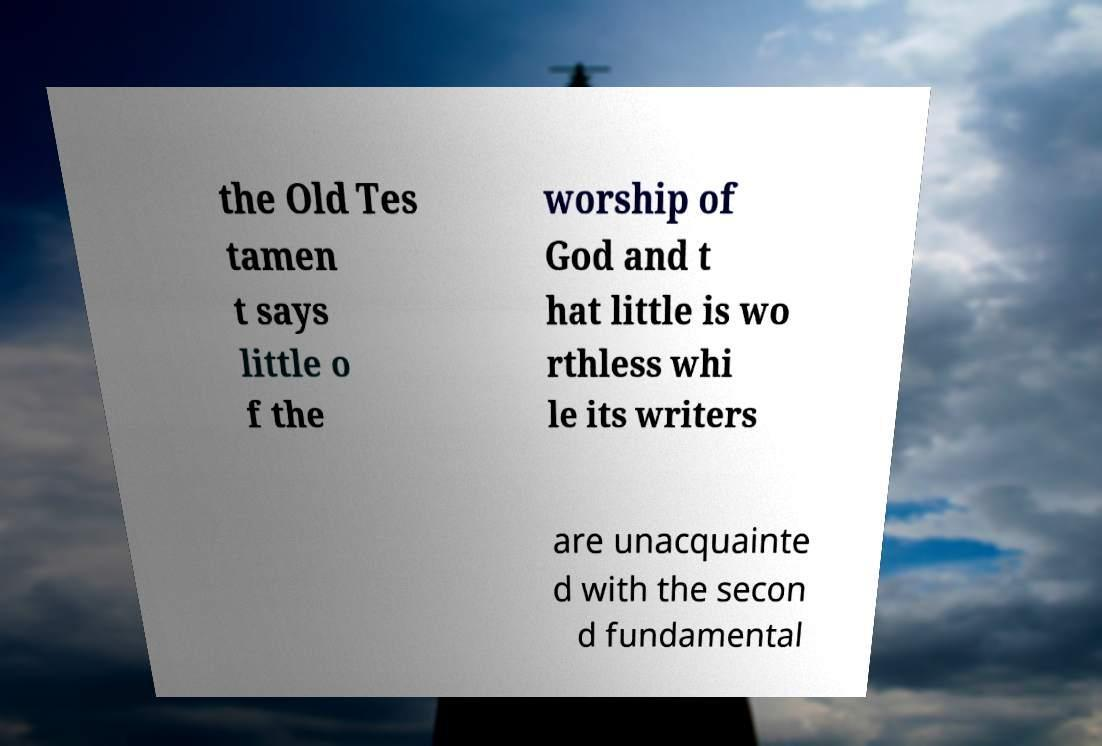For documentation purposes, I need the text within this image transcribed. Could you provide that? the Old Tes tamen t says little o f the worship of God and t hat little is wo rthless whi le its writers are unacquainte d with the secon d fundamental 